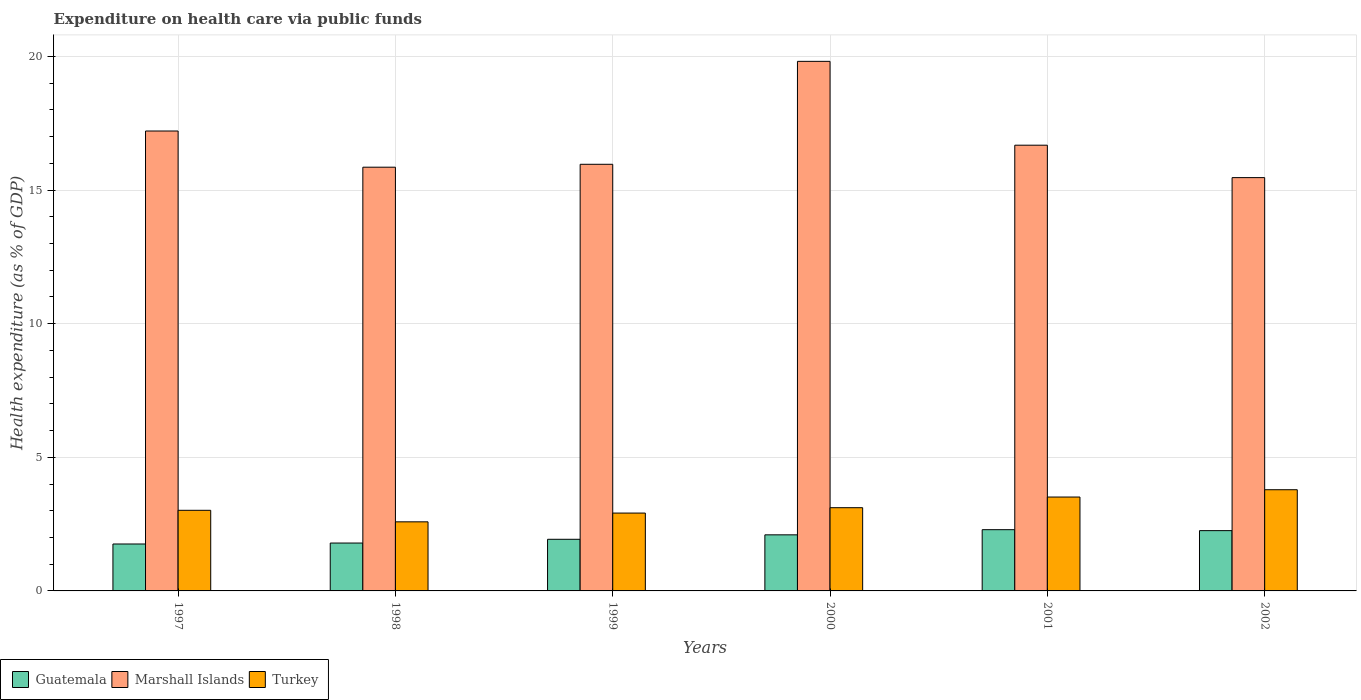How many groups of bars are there?
Offer a terse response. 6. Are the number of bars on each tick of the X-axis equal?
Your response must be concise. Yes. How many bars are there on the 4th tick from the left?
Offer a very short reply. 3. How many bars are there on the 5th tick from the right?
Give a very brief answer. 3. In how many cases, is the number of bars for a given year not equal to the number of legend labels?
Ensure brevity in your answer.  0. What is the expenditure made on health care in Turkey in 2002?
Offer a very short reply. 3.79. Across all years, what is the maximum expenditure made on health care in Guatemala?
Ensure brevity in your answer.  2.29. Across all years, what is the minimum expenditure made on health care in Marshall Islands?
Provide a succinct answer. 15.46. In which year was the expenditure made on health care in Guatemala minimum?
Make the answer very short. 1997. What is the total expenditure made on health care in Marshall Islands in the graph?
Keep it short and to the point. 100.98. What is the difference between the expenditure made on health care in Turkey in 1997 and that in 2002?
Make the answer very short. -0.77. What is the difference between the expenditure made on health care in Marshall Islands in 1998 and the expenditure made on health care in Guatemala in 1997?
Your answer should be compact. 14.1. What is the average expenditure made on health care in Guatemala per year?
Keep it short and to the point. 2.02. In the year 1998, what is the difference between the expenditure made on health care in Marshall Islands and expenditure made on health care in Turkey?
Offer a very short reply. 13.27. In how many years, is the expenditure made on health care in Marshall Islands greater than 14 %?
Keep it short and to the point. 6. What is the ratio of the expenditure made on health care in Guatemala in 1998 to that in 2001?
Provide a short and direct response. 0.78. What is the difference between the highest and the second highest expenditure made on health care in Guatemala?
Your answer should be compact. 0.04. What is the difference between the highest and the lowest expenditure made on health care in Marshall Islands?
Your response must be concise. 4.35. Is the sum of the expenditure made on health care in Turkey in 1997 and 2002 greater than the maximum expenditure made on health care in Marshall Islands across all years?
Give a very brief answer. No. What does the 2nd bar from the right in 1997 represents?
Your answer should be compact. Marshall Islands. Is it the case that in every year, the sum of the expenditure made on health care in Guatemala and expenditure made on health care in Marshall Islands is greater than the expenditure made on health care in Turkey?
Give a very brief answer. Yes. Are all the bars in the graph horizontal?
Ensure brevity in your answer.  No. What is the difference between two consecutive major ticks on the Y-axis?
Your answer should be compact. 5. Does the graph contain any zero values?
Keep it short and to the point. No. Does the graph contain grids?
Offer a very short reply. Yes. Where does the legend appear in the graph?
Ensure brevity in your answer.  Bottom left. How many legend labels are there?
Give a very brief answer. 3. What is the title of the graph?
Your answer should be very brief. Expenditure on health care via public funds. What is the label or title of the X-axis?
Provide a short and direct response. Years. What is the label or title of the Y-axis?
Your answer should be compact. Health expenditure (as % of GDP). What is the Health expenditure (as % of GDP) in Guatemala in 1997?
Provide a short and direct response. 1.76. What is the Health expenditure (as % of GDP) of Marshall Islands in 1997?
Keep it short and to the point. 17.21. What is the Health expenditure (as % of GDP) in Turkey in 1997?
Give a very brief answer. 3.02. What is the Health expenditure (as % of GDP) in Guatemala in 1998?
Keep it short and to the point. 1.79. What is the Health expenditure (as % of GDP) in Marshall Islands in 1998?
Your response must be concise. 15.85. What is the Health expenditure (as % of GDP) of Turkey in 1998?
Provide a succinct answer. 2.58. What is the Health expenditure (as % of GDP) in Guatemala in 1999?
Offer a terse response. 1.93. What is the Health expenditure (as % of GDP) in Marshall Islands in 1999?
Your answer should be very brief. 15.96. What is the Health expenditure (as % of GDP) in Turkey in 1999?
Ensure brevity in your answer.  2.91. What is the Health expenditure (as % of GDP) of Guatemala in 2000?
Provide a short and direct response. 2.1. What is the Health expenditure (as % of GDP) in Marshall Islands in 2000?
Provide a succinct answer. 19.81. What is the Health expenditure (as % of GDP) of Turkey in 2000?
Give a very brief answer. 3.11. What is the Health expenditure (as % of GDP) in Guatemala in 2001?
Your response must be concise. 2.29. What is the Health expenditure (as % of GDP) of Marshall Islands in 2001?
Your answer should be compact. 16.68. What is the Health expenditure (as % of GDP) in Turkey in 2001?
Your response must be concise. 3.51. What is the Health expenditure (as % of GDP) in Guatemala in 2002?
Provide a short and direct response. 2.26. What is the Health expenditure (as % of GDP) of Marshall Islands in 2002?
Your answer should be compact. 15.46. What is the Health expenditure (as % of GDP) in Turkey in 2002?
Provide a succinct answer. 3.79. Across all years, what is the maximum Health expenditure (as % of GDP) of Guatemala?
Offer a terse response. 2.29. Across all years, what is the maximum Health expenditure (as % of GDP) in Marshall Islands?
Offer a terse response. 19.81. Across all years, what is the maximum Health expenditure (as % of GDP) in Turkey?
Provide a succinct answer. 3.79. Across all years, what is the minimum Health expenditure (as % of GDP) in Guatemala?
Make the answer very short. 1.76. Across all years, what is the minimum Health expenditure (as % of GDP) of Marshall Islands?
Provide a short and direct response. 15.46. Across all years, what is the minimum Health expenditure (as % of GDP) of Turkey?
Ensure brevity in your answer.  2.58. What is the total Health expenditure (as % of GDP) in Guatemala in the graph?
Your answer should be compact. 12.12. What is the total Health expenditure (as % of GDP) of Marshall Islands in the graph?
Ensure brevity in your answer.  100.98. What is the total Health expenditure (as % of GDP) of Turkey in the graph?
Your response must be concise. 18.93. What is the difference between the Health expenditure (as % of GDP) in Guatemala in 1997 and that in 1998?
Give a very brief answer. -0.04. What is the difference between the Health expenditure (as % of GDP) of Marshall Islands in 1997 and that in 1998?
Provide a short and direct response. 1.35. What is the difference between the Health expenditure (as % of GDP) of Turkey in 1997 and that in 1998?
Offer a terse response. 0.43. What is the difference between the Health expenditure (as % of GDP) in Guatemala in 1997 and that in 1999?
Provide a short and direct response. -0.18. What is the difference between the Health expenditure (as % of GDP) in Marshall Islands in 1997 and that in 1999?
Your answer should be compact. 1.25. What is the difference between the Health expenditure (as % of GDP) in Turkey in 1997 and that in 1999?
Keep it short and to the point. 0.1. What is the difference between the Health expenditure (as % of GDP) of Guatemala in 1997 and that in 2000?
Ensure brevity in your answer.  -0.34. What is the difference between the Health expenditure (as % of GDP) in Marshall Islands in 1997 and that in 2000?
Offer a terse response. -2.61. What is the difference between the Health expenditure (as % of GDP) of Turkey in 1997 and that in 2000?
Offer a very short reply. -0.1. What is the difference between the Health expenditure (as % of GDP) in Guatemala in 1997 and that in 2001?
Your answer should be very brief. -0.54. What is the difference between the Health expenditure (as % of GDP) of Marshall Islands in 1997 and that in 2001?
Offer a very short reply. 0.53. What is the difference between the Health expenditure (as % of GDP) of Turkey in 1997 and that in 2001?
Keep it short and to the point. -0.5. What is the difference between the Health expenditure (as % of GDP) of Guatemala in 1997 and that in 2002?
Make the answer very short. -0.5. What is the difference between the Health expenditure (as % of GDP) in Marshall Islands in 1997 and that in 2002?
Keep it short and to the point. 1.74. What is the difference between the Health expenditure (as % of GDP) in Turkey in 1997 and that in 2002?
Provide a short and direct response. -0.77. What is the difference between the Health expenditure (as % of GDP) in Guatemala in 1998 and that in 1999?
Your answer should be compact. -0.14. What is the difference between the Health expenditure (as % of GDP) of Marshall Islands in 1998 and that in 1999?
Your response must be concise. -0.11. What is the difference between the Health expenditure (as % of GDP) of Turkey in 1998 and that in 1999?
Offer a terse response. -0.33. What is the difference between the Health expenditure (as % of GDP) in Guatemala in 1998 and that in 2000?
Provide a succinct answer. -0.31. What is the difference between the Health expenditure (as % of GDP) of Marshall Islands in 1998 and that in 2000?
Provide a short and direct response. -3.96. What is the difference between the Health expenditure (as % of GDP) in Turkey in 1998 and that in 2000?
Give a very brief answer. -0.53. What is the difference between the Health expenditure (as % of GDP) of Guatemala in 1998 and that in 2001?
Keep it short and to the point. -0.5. What is the difference between the Health expenditure (as % of GDP) in Marshall Islands in 1998 and that in 2001?
Your response must be concise. -0.82. What is the difference between the Health expenditure (as % of GDP) in Turkey in 1998 and that in 2001?
Provide a short and direct response. -0.93. What is the difference between the Health expenditure (as % of GDP) in Guatemala in 1998 and that in 2002?
Make the answer very short. -0.46. What is the difference between the Health expenditure (as % of GDP) in Marshall Islands in 1998 and that in 2002?
Offer a very short reply. 0.39. What is the difference between the Health expenditure (as % of GDP) in Turkey in 1998 and that in 2002?
Provide a short and direct response. -1.2. What is the difference between the Health expenditure (as % of GDP) of Guatemala in 1999 and that in 2000?
Your answer should be very brief. -0.17. What is the difference between the Health expenditure (as % of GDP) in Marshall Islands in 1999 and that in 2000?
Offer a terse response. -3.85. What is the difference between the Health expenditure (as % of GDP) in Turkey in 1999 and that in 2000?
Keep it short and to the point. -0.2. What is the difference between the Health expenditure (as % of GDP) in Guatemala in 1999 and that in 2001?
Keep it short and to the point. -0.36. What is the difference between the Health expenditure (as % of GDP) of Marshall Islands in 1999 and that in 2001?
Provide a short and direct response. -0.71. What is the difference between the Health expenditure (as % of GDP) of Turkey in 1999 and that in 2001?
Provide a short and direct response. -0.6. What is the difference between the Health expenditure (as % of GDP) in Guatemala in 1999 and that in 2002?
Your answer should be very brief. -0.32. What is the difference between the Health expenditure (as % of GDP) in Marshall Islands in 1999 and that in 2002?
Provide a succinct answer. 0.5. What is the difference between the Health expenditure (as % of GDP) of Turkey in 1999 and that in 2002?
Offer a very short reply. -0.87. What is the difference between the Health expenditure (as % of GDP) in Guatemala in 2000 and that in 2001?
Make the answer very short. -0.19. What is the difference between the Health expenditure (as % of GDP) of Marshall Islands in 2000 and that in 2001?
Offer a very short reply. 3.14. What is the difference between the Health expenditure (as % of GDP) in Turkey in 2000 and that in 2001?
Give a very brief answer. -0.4. What is the difference between the Health expenditure (as % of GDP) in Guatemala in 2000 and that in 2002?
Provide a succinct answer. -0.16. What is the difference between the Health expenditure (as % of GDP) in Marshall Islands in 2000 and that in 2002?
Provide a short and direct response. 4.35. What is the difference between the Health expenditure (as % of GDP) in Turkey in 2000 and that in 2002?
Provide a short and direct response. -0.67. What is the difference between the Health expenditure (as % of GDP) in Guatemala in 2001 and that in 2002?
Provide a succinct answer. 0.04. What is the difference between the Health expenditure (as % of GDP) in Marshall Islands in 2001 and that in 2002?
Ensure brevity in your answer.  1.21. What is the difference between the Health expenditure (as % of GDP) in Turkey in 2001 and that in 2002?
Your answer should be compact. -0.27. What is the difference between the Health expenditure (as % of GDP) of Guatemala in 1997 and the Health expenditure (as % of GDP) of Marshall Islands in 1998?
Ensure brevity in your answer.  -14.1. What is the difference between the Health expenditure (as % of GDP) in Guatemala in 1997 and the Health expenditure (as % of GDP) in Turkey in 1998?
Give a very brief answer. -0.83. What is the difference between the Health expenditure (as % of GDP) of Marshall Islands in 1997 and the Health expenditure (as % of GDP) of Turkey in 1998?
Keep it short and to the point. 14.62. What is the difference between the Health expenditure (as % of GDP) of Guatemala in 1997 and the Health expenditure (as % of GDP) of Marshall Islands in 1999?
Provide a succinct answer. -14.21. What is the difference between the Health expenditure (as % of GDP) of Guatemala in 1997 and the Health expenditure (as % of GDP) of Turkey in 1999?
Provide a succinct answer. -1.16. What is the difference between the Health expenditure (as % of GDP) in Marshall Islands in 1997 and the Health expenditure (as % of GDP) in Turkey in 1999?
Your response must be concise. 14.29. What is the difference between the Health expenditure (as % of GDP) of Guatemala in 1997 and the Health expenditure (as % of GDP) of Marshall Islands in 2000?
Ensure brevity in your answer.  -18.06. What is the difference between the Health expenditure (as % of GDP) in Guatemala in 1997 and the Health expenditure (as % of GDP) in Turkey in 2000?
Make the answer very short. -1.36. What is the difference between the Health expenditure (as % of GDP) in Marshall Islands in 1997 and the Health expenditure (as % of GDP) in Turkey in 2000?
Offer a very short reply. 14.09. What is the difference between the Health expenditure (as % of GDP) of Guatemala in 1997 and the Health expenditure (as % of GDP) of Marshall Islands in 2001?
Give a very brief answer. -14.92. What is the difference between the Health expenditure (as % of GDP) in Guatemala in 1997 and the Health expenditure (as % of GDP) in Turkey in 2001?
Your answer should be very brief. -1.76. What is the difference between the Health expenditure (as % of GDP) in Marshall Islands in 1997 and the Health expenditure (as % of GDP) in Turkey in 2001?
Make the answer very short. 13.7. What is the difference between the Health expenditure (as % of GDP) of Guatemala in 1997 and the Health expenditure (as % of GDP) of Marshall Islands in 2002?
Your response must be concise. -13.71. What is the difference between the Health expenditure (as % of GDP) of Guatemala in 1997 and the Health expenditure (as % of GDP) of Turkey in 2002?
Ensure brevity in your answer.  -2.03. What is the difference between the Health expenditure (as % of GDP) of Marshall Islands in 1997 and the Health expenditure (as % of GDP) of Turkey in 2002?
Your response must be concise. 13.42. What is the difference between the Health expenditure (as % of GDP) in Guatemala in 1998 and the Health expenditure (as % of GDP) in Marshall Islands in 1999?
Provide a short and direct response. -14.17. What is the difference between the Health expenditure (as % of GDP) in Guatemala in 1998 and the Health expenditure (as % of GDP) in Turkey in 1999?
Your answer should be very brief. -1.12. What is the difference between the Health expenditure (as % of GDP) in Marshall Islands in 1998 and the Health expenditure (as % of GDP) in Turkey in 1999?
Your response must be concise. 12.94. What is the difference between the Health expenditure (as % of GDP) of Guatemala in 1998 and the Health expenditure (as % of GDP) of Marshall Islands in 2000?
Ensure brevity in your answer.  -18.02. What is the difference between the Health expenditure (as % of GDP) in Guatemala in 1998 and the Health expenditure (as % of GDP) in Turkey in 2000?
Provide a short and direct response. -1.32. What is the difference between the Health expenditure (as % of GDP) of Marshall Islands in 1998 and the Health expenditure (as % of GDP) of Turkey in 2000?
Give a very brief answer. 12.74. What is the difference between the Health expenditure (as % of GDP) of Guatemala in 1998 and the Health expenditure (as % of GDP) of Marshall Islands in 2001?
Make the answer very short. -14.89. What is the difference between the Health expenditure (as % of GDP) of Guatemala in 1998 and the Health expenditure (as % of GDP) of Turkey in 2001?
Your response must be concise. -1.72. What is the difference between the Health expenditure (as % of GDP) in Marshall Islands in 1998 and the Health expenditure (as % of GDP) in Turkey in 2001?
Give a very brief answer. 12.34. What is the difference between the Health expenditure (as % of GDP) in Guatemala in 1998 and the Health expenditure (as % of GDP) in Marshall Islands in 2002?
Provide a succinct answer. -13.67. What is the difference between the Health expenditure (as % of GDP) in Guatemala in 1998 and the Health expenditure (as % of GDP) in Turkey in 2002?
Provide a short and direct response. -1.99. What is the difference between the Health expenditure (as % of GDP) of Marshall Islands in 1998 and the Health expenditure (as % of GDP) of Turkey in 2002?
Provide a succinct answer. 12.07. What is the difference between the Health expenditure (as % of GDP) in Guatemala in 1999 and the Health expenditure (as % of GDP) in Marshall Islands in 2000?
Ensure brevity in your answer.  -17.88. What is the difference between the Health expenditure (as % of GDP) in Guatemala in 1999 and the Health expenditure (as % of GDP) in Turkey in 2000?
Make the answer very short. -1.18. What is the difference between the Health expenditure (as % of GDP) of Marshall Islands in 1999 and the Health expenditure (as % of GDP) of Turkey in 2000?
Your response must be concise. 12.85. What is the difference between the Health expenditure (as % of GDP) of Guatemala in 1999 and the Health expenditure (as % of GDP) of Marshall Islands in 2001?
Make the answer very short. -14.75. What is the difference between the Health expenditure (as % of GDP) in Guatemala in 1999 and the Health expenditure (as % of GDP) in Turkey in 2001?
Your answer should be very brief. -1.58. What is the difference between the Health expenditure (as % of GDP) of Marshall Islands in 1999 and the Health expenditure (as % of GDP) of Turkey in 2001?
Give a very brief answer. 12.45. What is the difference between the Health expenditure (as % of GDP) in Guatemala in 1999 and the Health expenditure (as % of GDP) in Marshall Islands in 2002?
Ensure brevity in your answer.  -13.53. What is the difference between the Health expenditure (as % of GDP) in Guatemala in 1999 and the Health expenditure (as % of GDP) in Turkey in 2002?
Keep it short and to the point. -1.85. What is the difference between the Health expenditure (as % of GDP) of Marshall Islands in 1999 and the Health expenditure (as % of GDP) of Turkey in 2002?
Your response must be concise. 12.18. What is the difference between the Health expenditure (as % of GDP) of Guatemala in 2000 and the Health expenditure (as % of GDP) of Marshall Islands in 2001?
Provide a short and direct response. -14.58. What is the difference between the Health expenditure (as % of GDP) in Guatemala in 2000 and the Health expenditure (as % of GDP) in Turkey in 2001?
Offer a terse response. -1.41. What is the difference between the Health expenditure (as % of GDP) in Marshall Islands in 2000 and the Health expenditure (as % of GDP) in Turkey in 2001?
Make the answer very short. 16.3. What is the difference between the Health expenditure (as % of GDP) of Guatemala in 2000 and the Health expenditure (as % of GDP) of Marshall Islands in 2002?
Give a very brief answer. -13.37. What is the difference between the Health expenditure (as % of GDP) in Guatemala in 2000 and the Health expenditure (as % of GDP) in Turkey in 2002?
Keep it short and to the point. -1.69. What is the difference between the Health expenditure (as % of GDP) of Marshall Islands in 2000 and the Health expenditure (as % of GDP) of Turkey in 2002?
Offer a very short reply. 16.03. What is the difference between the Health expenditure (as % of GDP) of Guatemala in 2001 and the Health expenditure (as % of GDP) of Marshall Islands in 2002?
Keep it short and to the point. -13.17. What is the difference between the Health expenditure (as % of GDP) in Guatemala in 2001 and the Health expenditure (as % of GDP) in Turkey in 2002?
Offer a very short reply. -1.5. What is the difference between the Health expenditure (as % of GDP) in Marshall Islands in 2001 and the Health expenditure (as % of GDP) in Turkey in 2002?
Your response must be concise. 12.89. What is the average Health expenditure (as % of GDP) of Guatemala per year?
Your answer should be very brief. 2.02. What is the average Health expenditure (as % of GDP) of Marshall Islands per year?
Your answer should be very brief. 16.83. What is the average Health expenditure (as % of GDP) of Turkey per year?
Ensure brevity in your answer.  3.15. In the year 1997, what is the difference between the Health expenditure (as % of GDP) in Guatemala and Health expenditure (as % of GDP) in Marshall Islands?
Provide a succinct answer. -15.45. In the year 1997, what is the difference between the Health expenditure (as % of GDP) in Guatemala and Health expenditure (as % of GDP) in Turkey?
Give a very brief answer. -1.26. In the year 1997, what is the difference between the Health expenditure (as % of GDP) in Marshall Islands and Health expenditure (as % of GDP) in Turkey?
Make the answer very short. 14.19. In the year 1998, what is the difference between the Health expenditure (as % of GDP) of Guatemala and Health expenditure (as % of GDP) of Marshall Islands?
Keep it short and to the point. -14.06. In the year 1998, what is the difference between the Health expenditure (as % of GDP) of Guatemala and Health expenditure (as % of GDP) of Turkey?
Provide a short and direct response. -0.79. In the year 1998, what is the difference between the Health expenditure (as % of GDP) of Marshall Islands and Health expenditure (as % of GDP) of Turkey?
Keep it short and to the point. 13.27. In the year 1999, what is the difference between the Health expenditure (as % of GDP) of Guatemala and Health expenditure (as % of GDP) of Marshall Islands?
Keep it short and to the point. -14.03. In the year 1999, what is the difference between the Health expenditure (as % of GDP) in Guatemala and Health expenditure (as % of GDP) in Turkey?
Provide a succinct answer. -0.98. In the year 1999, what is the difference between the Health expenditure (as % of GDP) of Marshall Islands and Health expenditure (as % of GDP) of Turkey?
Provide a succinct answer. 13.05. In the year 2000, what is the difference between the Health expenditure (as % of GDP) in Guatemala and Health expenditure (as % of GDP) in Marshall Islands?
Keep it short and to the point. -17.72. In the year 2000, what is the difference between the Health expenditure (as % of GDP) of Guatemala and Health expenditure (as % of GDP) of Turkey?
Keep it short and to the point. -1.02. In the year 2000, what is the difference between the Health expenditure (as % of GDP) in Marshall Islands and Health expenditure (as % of GDP) in Turkey?
Offer a very short reply. 16.7. In the year 2001, what is the difference between the Health expenditure (as % of GDP) in Guatemala and Health expenditure (as % of GDP) in Marshall Islands?
Keep it short and to the point. -14.39. In the year 2001, what is the difference between the Health expenditure (as % of GDP) of Guatemala and Health expenditure (as % of GDP) of Turkey?
Provide a short and direct response. -1.22. In the year 2001, what is the difference between the Health expenditure (as % of GDP) in Marshall Islands and Health expenditure (as % of GDP) in Turkey?
Ensure brevity in your answer.  13.16. In the year 2002, what is the difference between the Health expenditure (as % of GDP) of Guatemala and Health expenditure (as % of GDP) of Marshall Islands?
Give a very brief answer. -13.21. In the year 2002, what is the difference between the Health expenditure (as % of GDP) in Guatemala and Health expenditure (as % of GDP) in Turkey?
Your response must be concise. -1.53. In the year 2002, what is the difference between the Health expenditure (as % of GDP) of Marshall Islands and Health expenditure (as % of GDP) of Turkey?
Provide a succinct answer. 11.68. What is the ratio of the Health expenditure (as % of GDP) of Guatemala in 1997 to that in 1998?
Ensure brevity in your answer.  0.98. What is the ratio of the Health expenditure (as % of GDP) of Marshall Islands in 1997 to that in 1998?
Your answer should be compact. 1.09. What is the ratio of the Health expenditure (as % of GDP) of Turkey in 1997 to that in 1998?
Offer a very short reply. 1.17. What is the ratio of the Health expenditure (as % of GDP) of Guatemala in 1997 to that in 1999?
Your response must be concise. 0.91. What is the ratio of the Health expenditure (as % of GDP) in Marshall Islands in 1997 to that in 1999?
Your answer should be very brief. 1.08. What is the ratio of the Health expenditure (as % of GDP) of Turkey in 1997 to that in 1999?
Keep it short and to the point. 1.04. What is the ratio of the Health expenditure (as % of GDP) of Guatemala in 1997 to that in 2000?
Provide a succinct answer. 0.84. What is the ratio of the Health expenditure (as % of GDP) of Marshall Islands in 1997 to that in 2000?
Ensure brevity in your answer.  0.87. What is the ratio of the Health expenditure (as % of GDP) of Turkey in 1997 to that in 2000?
Make the answer very short. 0.97. What is the ratio of the Health expenditure (as % of GDP) in Guatemala in 1997 to that in 2001?
Offer a terse response. 0.77. What is the ratio of the Health expenditure (as % of GDP) in Marshall Islands in 1997 to that in 2001?
Give a very brief answer. 1.03. What is the ratio of the Health expenditure (as % of GDP) in Turkey in 1997 to that in 2001?
Offer a very short reply. 0.86. What is the ratio of the Health expenditure (as % of GDP) of Guatemala in 1997 to that in 2002?
Your answer should be very brief. 0.78. What is the ratio of the Health expenditure (as % of GDP) of Marshall Islands in 1997 to that in 2002?
Keep it short and to the point. 1.11. What is the ratio of the Health expenditure (as % of GDP) of Turkey in 1997 to that in 2002?
Ensure brevity in your answer.  0.8. What is the ratio of the Health expenditure (as % of GDP) of Guatemala in 1998 to that in 1999?
Offer a very short reply. 0.93. What is the ratio of the Health expenditure (as % of GDP) in Turkey in 1998 to that in 1999?
Your answer should be very brief. 0.89. What is the ratio of the Health expenditure (as % of GDP) in Guatemala in 1998 to that in 2000?
Ensure brevity in your answer.  0.85. What is the ratio of the Health expenditure (as % of GDP) in Marshall Islands in 1998 to that in 2000?
Make the answer very short. 0.8. What is the ratio of the Health expenditure (as % of GDP) of Turkey in 1998 to that in 2000?
Make the answer very short. 0.83. What is the ratio of the Health expenditure (as % of GDP) of Guatemala in 1998 to that in 2001?
Your answer should be very brief. 0.78. What is the ratio of the Health expenditure (as % of GDP) in Marshall Islands in 1998 to that in 2001?
Provide a short and direct response. 0.95. What is the ratio of the Health expenditure (as % of GDP) in Turkey in 1998 to that in 2001?
Offer a very short reply. 0.74. What is the ratio of the Health expenditure (as % of GDP) of Guatemala in 1998 to that in 2002?
Offer a very short reply. 0.79. What is the ratio of the Health expenditure (as % of GDP) in Marshall Islands in 1998 to that in 2002?
Provide a succinct answer. 1.03. What is the ratio of the Health expenditure (as % of GDP) of Turkey in 1998 to that in 2002?
Provide a succinct answer. 0.68. What is the ratio of the Health expenditure (as % of GDP) of Guatemala in 1999 to that in 2000?
Keep it short and to the point. 0.92. What is the ratio of the Health expenditure (as % of GDP) in Marshall Islands in 1999 to that in 2000?
Offer a very short reply. 0.81. What is the ratio of the Health expenditure (as % of GDP) in Turkey in 1999 to that in 2000?
Keep it short and to the point. 0.94. What is the ratio of the Health expenditure (as % of GDP) in Guatemala in 1999 to that in 2001?
Ensure brevity in your answer.  0.84. What is the ratio of the Health expenditure (as % of GDP) in Marshall Islands in 1999 to that in 2001?
Give a very brief answer. 0.96. What is the ratio of the Health expenditure (as % of GDP) in Turkey in 1999 to that in 2001?
Provide a short and direct response. 0.83. What is the ratio of the Health expenditure (as % of GDP) in Guatemala in 1999 to that in 2002?
Ensure brevity in your answer.  0.86. What is the ratio of the Health expenditure (as % of GDP) in Marshall Islands in 1999 to that in 2002?
Keep it short and to the point. 1.03. What is the ratio of the Health expenditure (as % of GDP) of Turkey in 1999 to that in 2002?
Your response must be concise. 0.77. What is the ratio of the Health expenditure (as % of GDP) of Guatemala in 2000 to that in 2001?
Offer a terse response. 0.92. What is the ratio of the Health expenditure (as % of GDP) of Marshall Islands in 2000 to that in 2001?
Offer a very short reply. 1.19. What is the ratio of the Health expenditure (as % of GDP) in Turkey in 2000 to that in 2001?
Provide a short and direct response. 0.89. What is the ratio of the Health expenditure (as % of GDP) of Guatemala in 2000 to that in 2002?
Your response must be concise. 0.93. What is the ratio of the Health expenditure (as % of GDP) in Marshall Islands in 2000 to that in 2002?
Make the answer very short. 1.28. What is the ratio of the Health expenditure (as % of GDP) in Turkey in 2000 to that in 2002?
Your answer should be compact. 0.82. What is the ratio of the Health expenditure (as % of GDP) in Guatemala in 2001 to that in 2002?
Your answer should be very brief. 1.02. What is the ratio of the Health expenditure (as % of GDP) of Marshall Islands in 2001 to that in 2002?
Provide a short and direct response. 1.08. What is the ratio of the Health expenditure (as % of GDP) of Turkey in 2001 to that in 2002?
Your answer should be compact. 0.93. What is the difference between the highest and the second highest Health expenditure (as % of GDP) of Guatemala?
Your answer should be compact. 0.04. What is the difference between the highest and the second highest Health expenditure (as % of GDP) of Marshall Islands?
Give a very brief answer. 2.61. What is the difference between the highest and the second highest Health expenditure (as % of GDP) of Turkey?
Make the answer very short. 0.27. What is the difference between the highest and the lowest Health expenditure (as % of GDP) in Guatemala?
Your response must be concise. 0.54. What is the difference between the highest and the lowest Health expenditure (as % of GDP) in Marshall Islands?
Your answer should be compact. 4.35. What is the difference between the highest and the lowest Health expenditure (as % of GDP) of Turkey?
Offer a terse response. 1.2. 